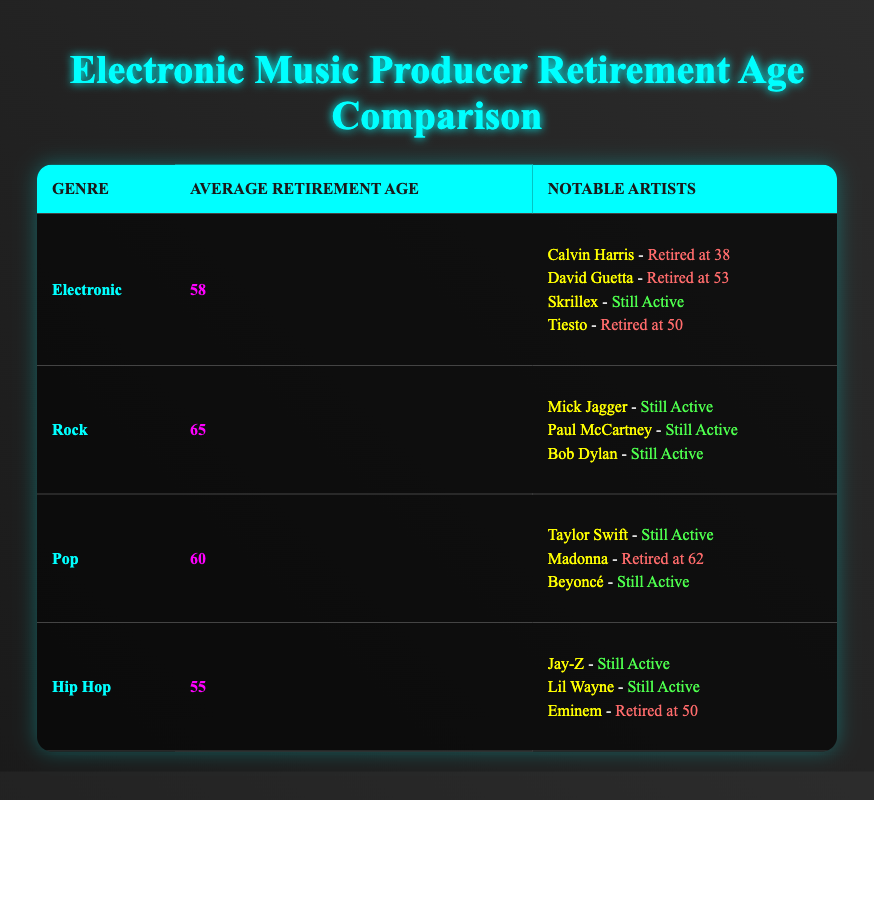What is the average retirement age for electronic music producers? According to the table, the average retirement age for electronic music producers is listed as 58.
Answer: 58 Which genre has the highest average retirement age? Looking at the table, rock has the highest average retirement age at 65.
Answer: 65 How old was David Guetta when he retired? The table states that David Guetta retired at the age of 53.
Answer: 53 Is Eminem retired? From the table, it can be seen that Eminem retired at the age of 50, so he is indeed retired.
Answer: Yes What is the difference in average retirement age between electronic producers and hip hop artists? The average retirement age for electronic producers is 58 and for hip hop artists it is 55. So the difference is 58 - 55 = 3.
Answer: 3 Which artist in the electronic genre retired the youngest, and at what age? Reviewing the table, Calvin Harris retired at the age of 38, making him the youngest among the electronic artists listed.
Answer: 38 How many renowned artists from the rock genre are still active? The table lists Mick Jagger, Paul McCartney, and Bob Dylan as notable rock artists, all of whom are still active. Thus, there are three still active.
Answer: 3 What is the average retirement age of the rock and pop genres combined? The average retirement age for rock is 65 and for pop is 60, so the combined average is (65 + 60) / 2 = 62.5.
Answer: 62.5 Which genre has the lowest average retirement age, and what is it? By examining the table, hip hop has the lowest average retirement age at 55.
Answer: 55 